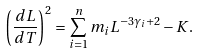<formula> <loc_0><loc_0><loc_500><loc_500>\left ( \frac { d L } { d T } \right ) ^ { 2 } = \sum _ { i = 1 } ^ { n } m _ { i } L ^ { - 3 \gamma _ { i } + 2 } - K .</formula> 